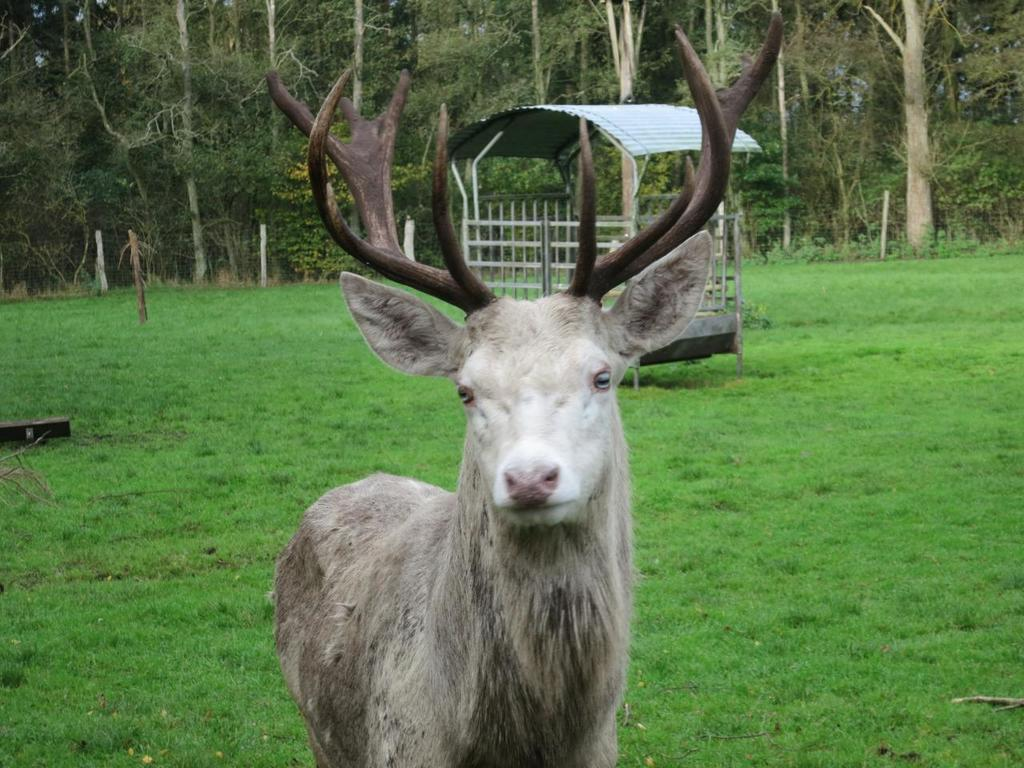What type of vegetation is present in the image? There is grass in the image. What structure can be seen in the middle of the image? There is a shelter in the middle of the image. What can be seen at the top of the image? There are trees at the top of the image. What type of living creature is at the bottom of the image? There is an animal at the bottom of the image. What type of shoes is the animal wearing in the image? There are no shoes present in the image, and animals do not wear shoes. What level of the image does the animal occupy? The animal is at the bottom of the image, so it occupies the lowest level. 